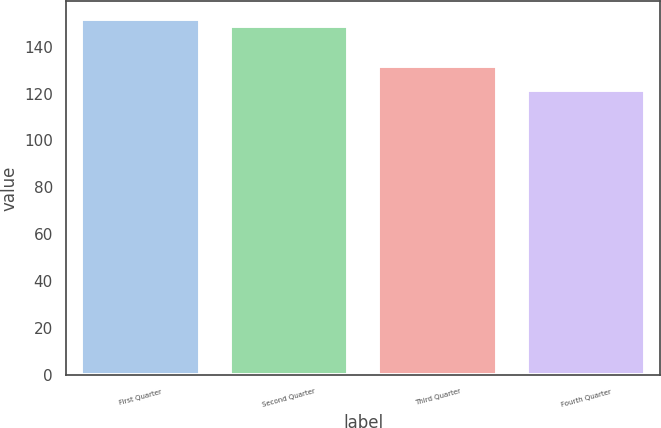Convert chart to OTSL. <chart><loc_0><loc_0><loc_500><loc_500><bar_chart><fcel>First Quarter<fcel>Second Quarter<fcel>Third Quarter<fcel>Fourth Quarter<nl><fcel>151.76<fcel>148.91<fcel>131.53<fcel>121.36<nl></chart> 